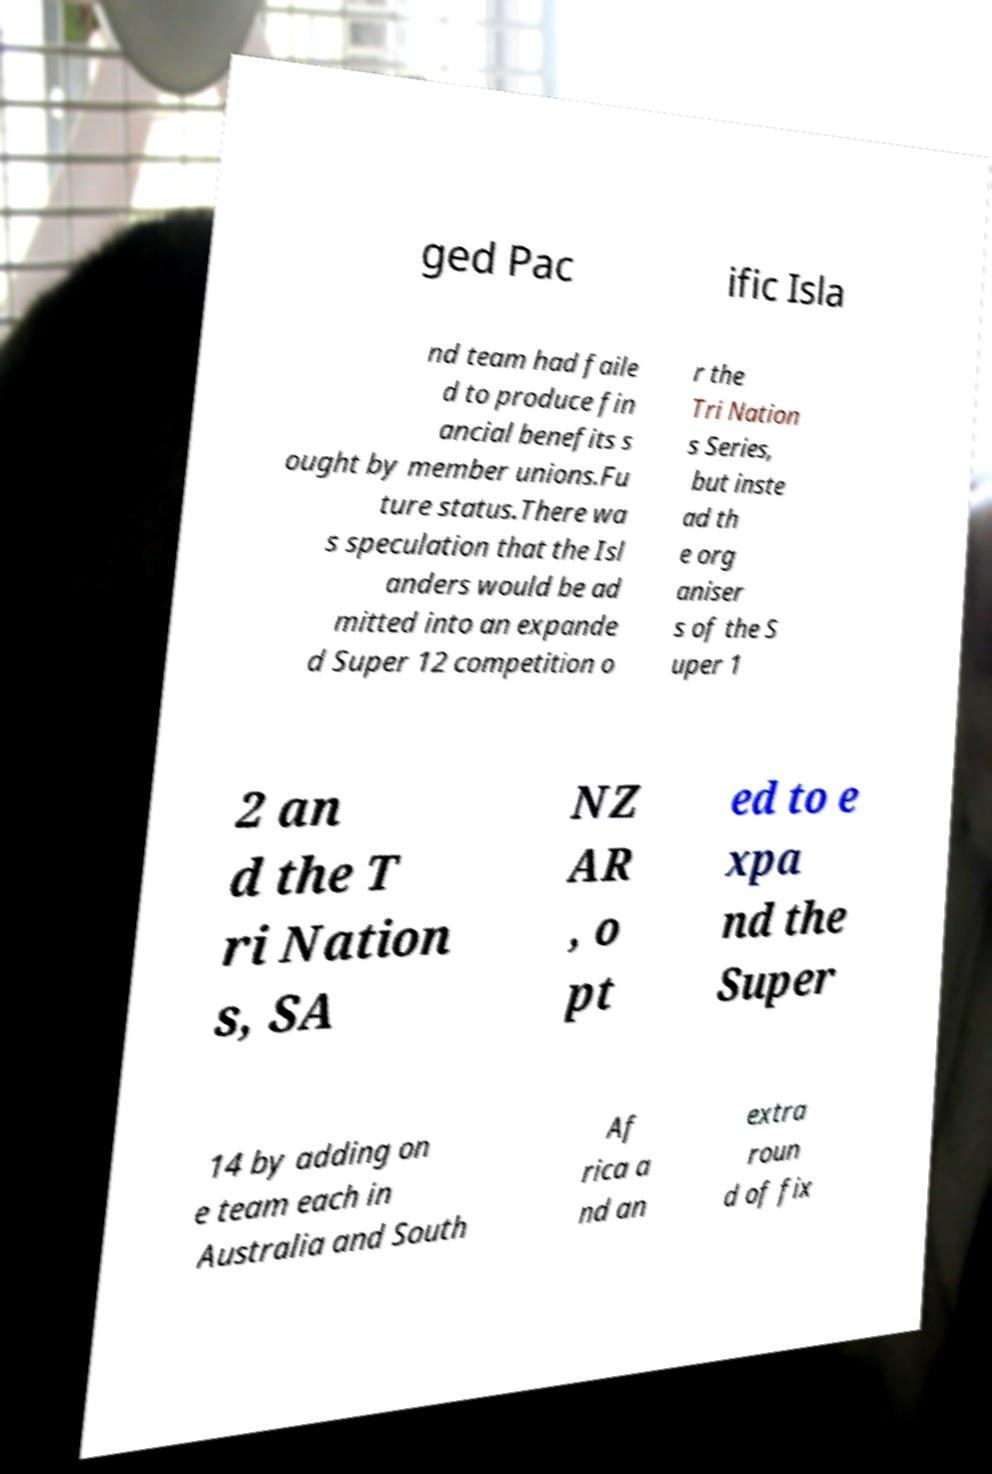What messages or text are displayed in this image? I need them in a readable, typed format. ged Pac ific Isla nd team had faile d to produce fin ancial benefits s ought by member unions.Fu ture status.There wa s speculation that the Isl anders would be ad mitted into an expande d Super 12 competition o r the Tri Nation s Series, but inste ad th e org aniser s of the S uper 1 2 an d the T ri Nation s, SA NZ AR , o pt ed to e xpa nd the Super 14 by adding on e team each in Australia and South Af rica a nd an extra roun d of fix 